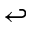<formula> <loc_0><loc_0><loc_500><loc_500>\hookleftarrow</formula> 